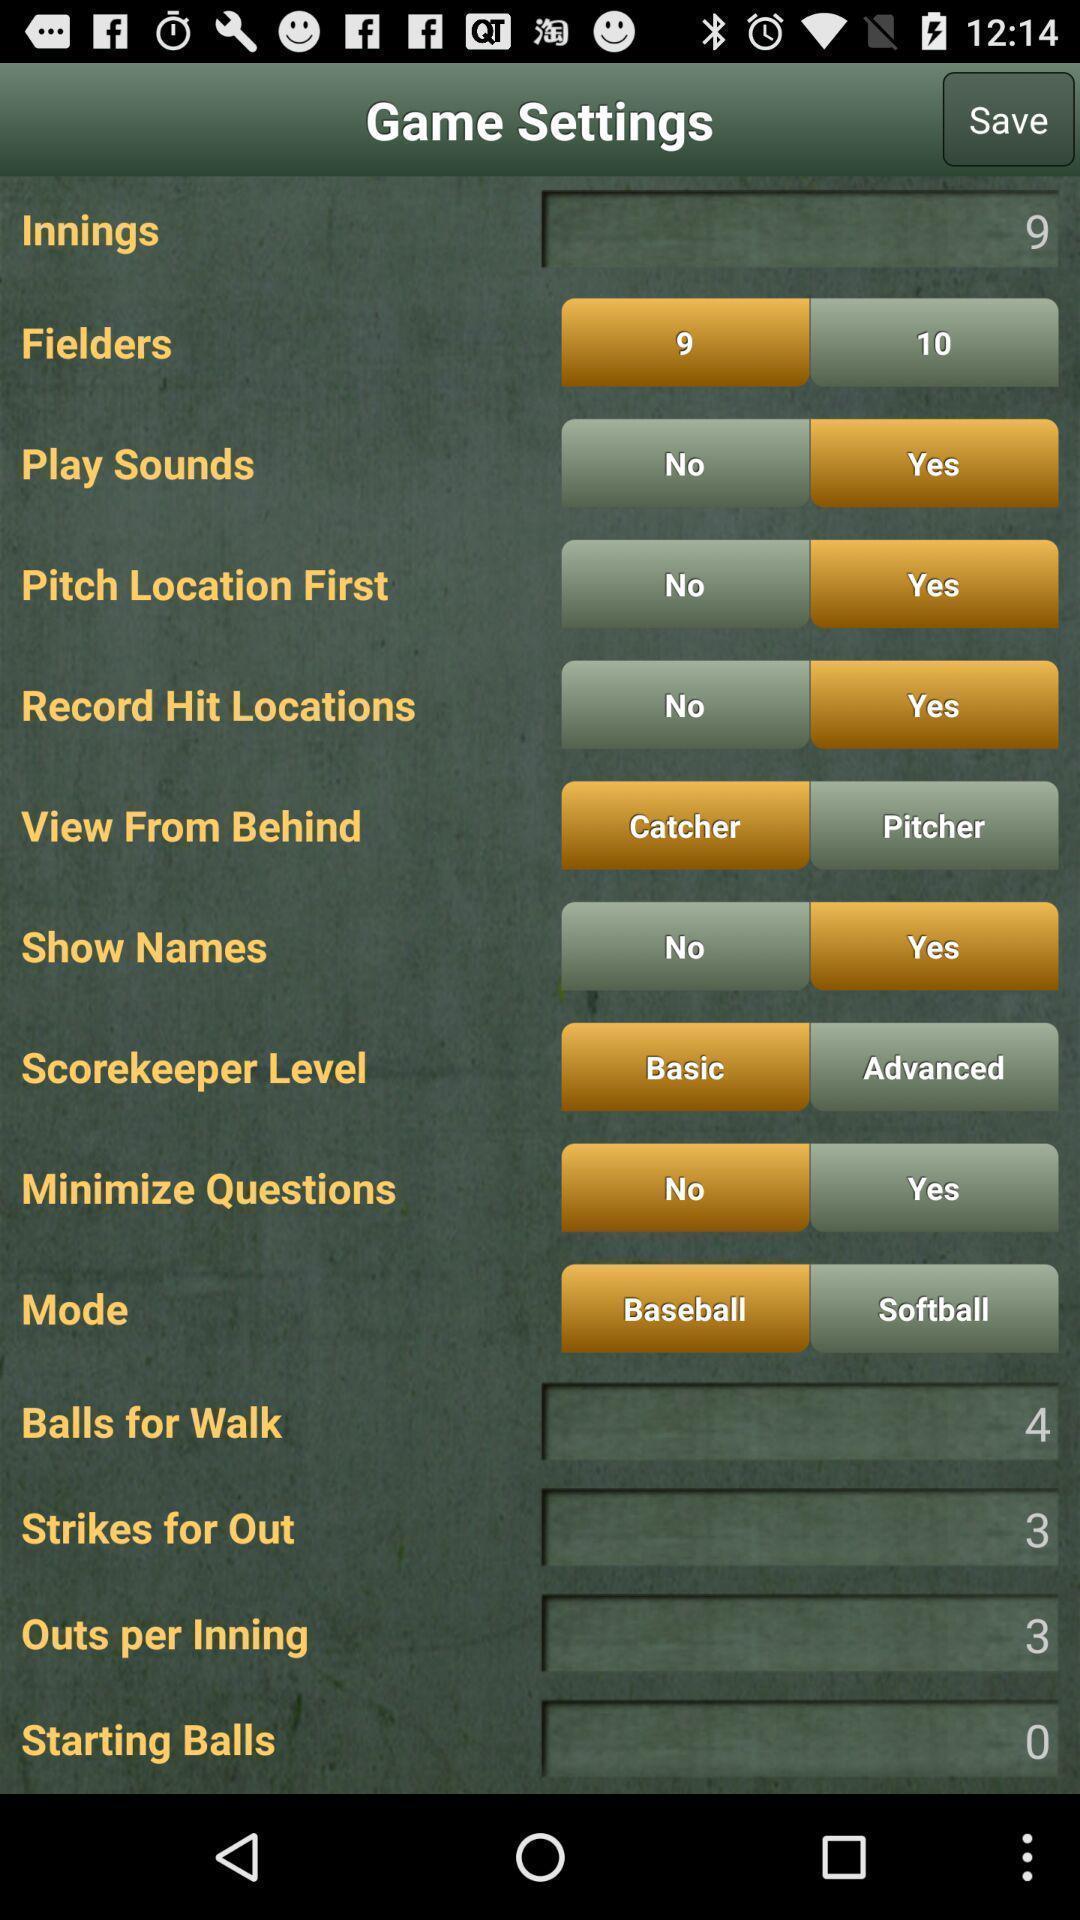Give me a narrative description of this picture. Various settings page displayed of a gaming application. 